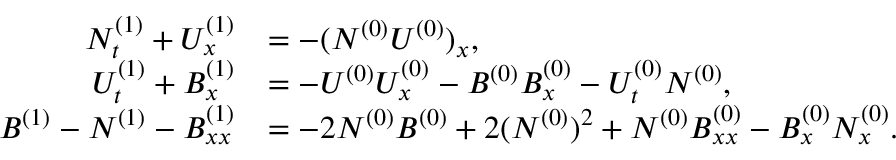Convert formula to latex. <formula><loc_0><loc_0><loc_500><loc_500>\begin{array} { r l } { N _ { t } ^ { ( 1 ) } + U _ { x } ^ { ( 1 ) } } & { = - ( N ^ { ( 0 ) } U ^ { ( 0 ) } ) _ { x } , } \\ { U _ { t } ^ { ( 1 ) } + B _ { x } ^ { ( 1 ) } } & { = - U ^ { ( 0 ) } U _ { x } ^ { ( 0 ) } - B ^ { ( 0 ) } B _ { x } ^ { ( 0 ) } - U _ { t } ^ { ( 0 ) } N ^ { ( 0 ) } , } \\ { B ^ { ( 1 ) } - N ^ { ( 1 ) } - B _ { x x } ^ { ( 1 ) } } & { = - 2 N ^ { ( 0 ) } B ^ { ( 0 ) } + 2 ( N ^ { ( 0 ) } ) ^ { 2 } + N ^ { ( 0 ) } B _ { x x } ^ { ( 0 ) } - B _ { x } ^ { ( 0 ) } N _ { x } ^ { ( 0 ) } . } \end{array}</formula> 